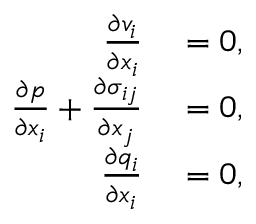<formula> <loc_0><loc_0><loc_500><loc_500>\begin{array} { r l } { \frac { \partial v _ { i } } { \partial x _ { i } } } & = 0 , } \\ { \frac { \partial p } { \partial x _ { i } } + \frac { \partial \sigma _ { i j } } { \partial x _ { j } } } & = 0 , } \\ { \frac { \partial q _ { i } } { \partial x _ { i } } } & = 0 , } \end{array}</formula> 